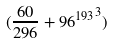Convert formula to latex. <formula><loc_0><loc_0><loc_500><loc_500>( \frac { 6 0 } { 2 9 6 } + { 9 6 ^ { 1 9 3 } } ^ { 3 } )</formula> 